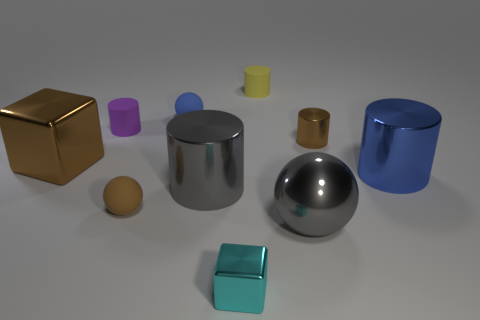Subtract 1 cylinders. How many cylinders are left? 4 Subtract all blue cylinders. How many cylinders are left? 4 Subtract all purple cylinders. How many cylinders are left? 4 Subtract all cyan cylinders. Subtract all purple balls. How many cylinders are left? 5 Subtract all cubes. How many objects are left? 8 Subtract all gray matte cubes. Subtract all metallic blocks. How many objects are left? 8 Add 5 tiny metal things. How many tiny metal things are left? 7 Add 3 tiny purple matte cylinders. How many tiny purple matte cylinders exist? 4 Subtract 1 brown balls. How many objects are left? 9 